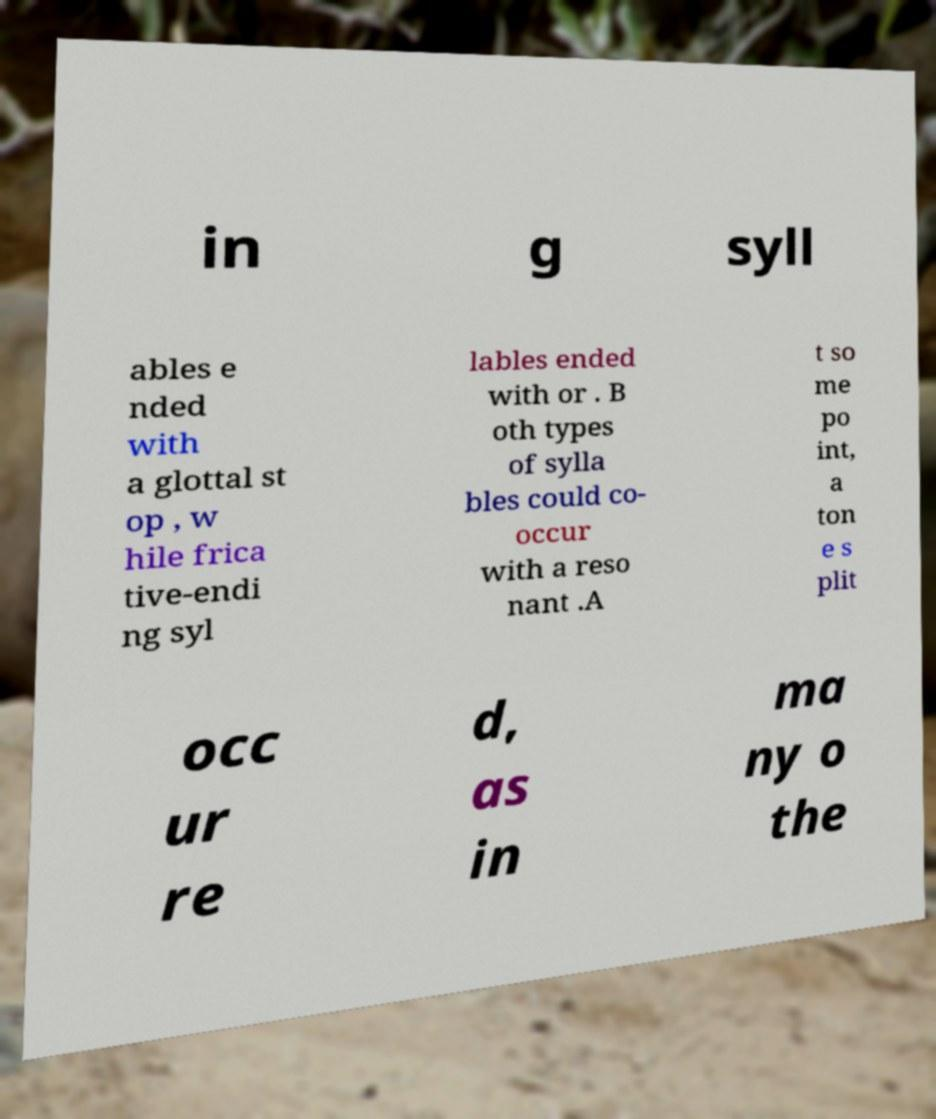Could you extract and type out the text from this image? in g syll ables e nded with a glottal st op , w hile frica tive-endi ng syl lables ended with or . B oth types of sylla bles could co- occur with a reso nant .A t so me po int, a ton e s plit occ ur re d, as in ma ny o the 